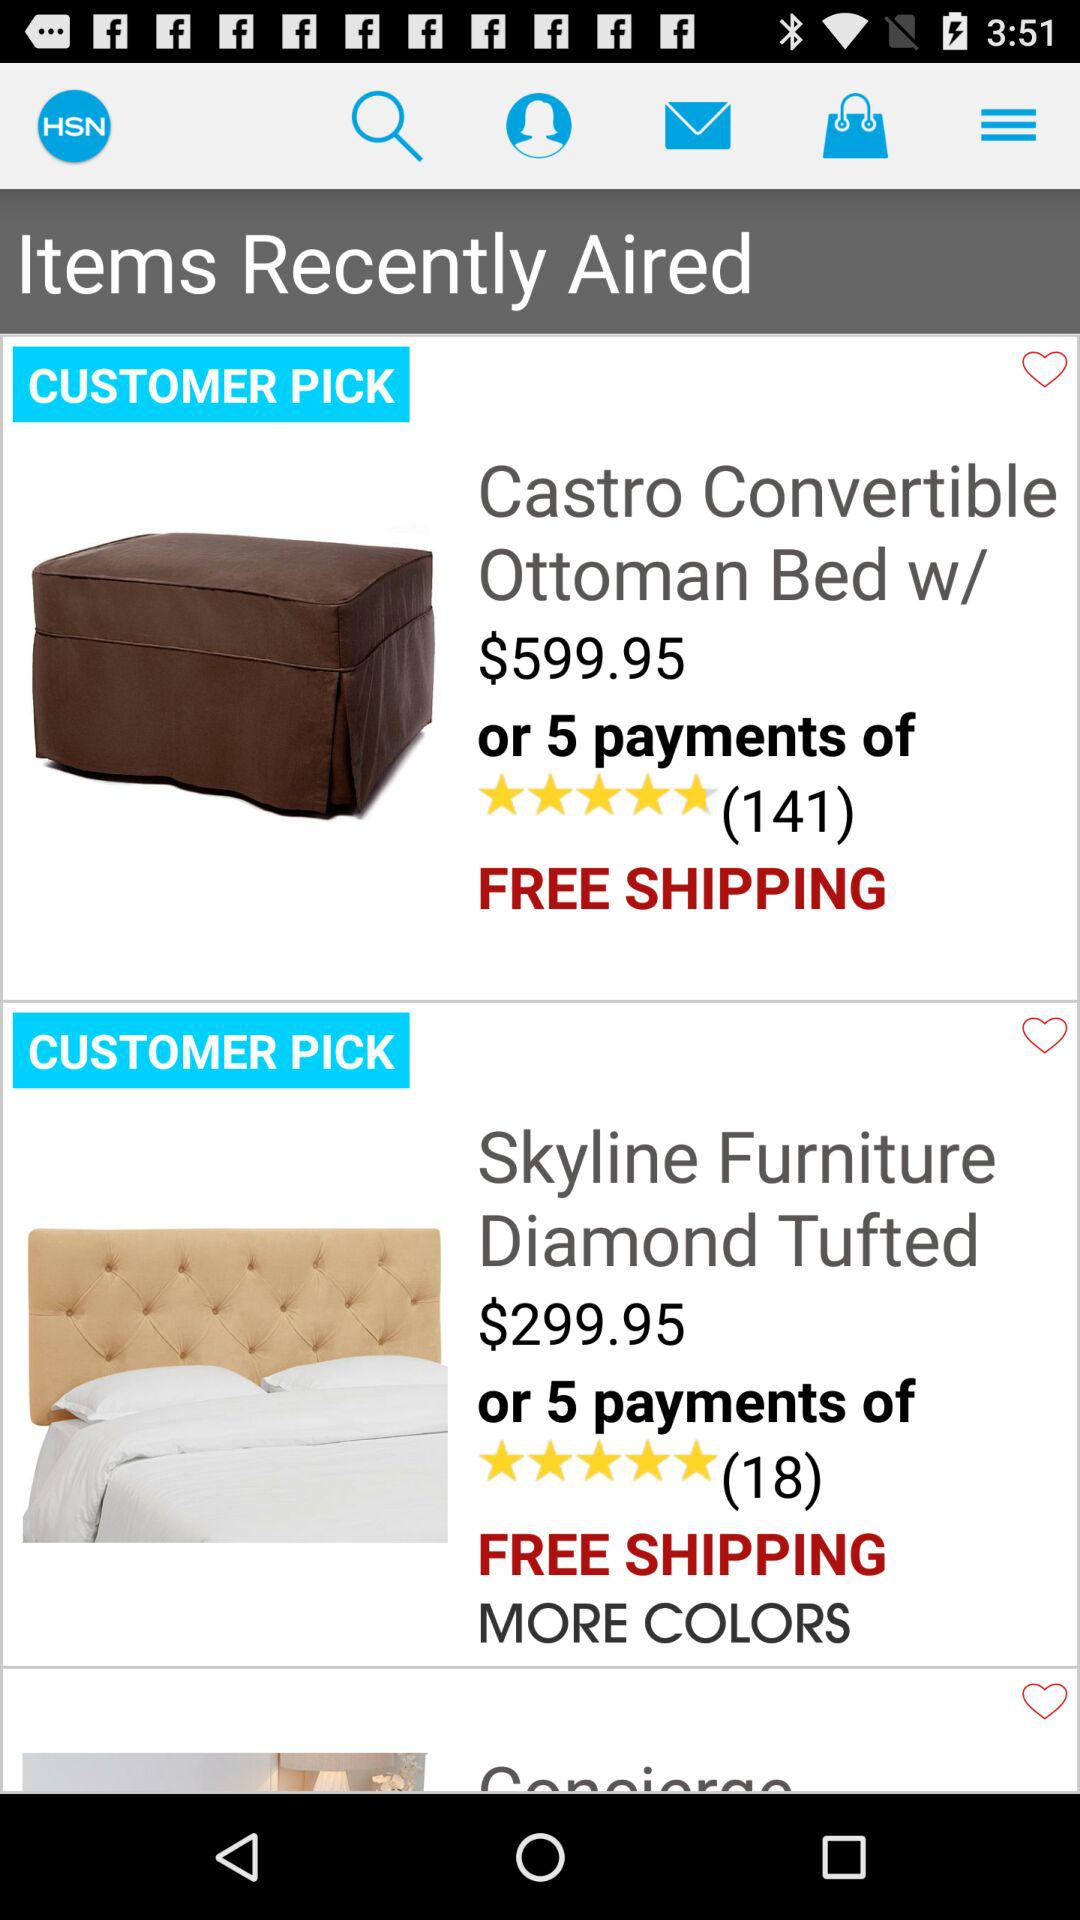What is the number of people who have rated the "Castro Convertible Ottoman Bed"? There are 141 people who have rated the "Castro Convertible Ottoman Bed". 